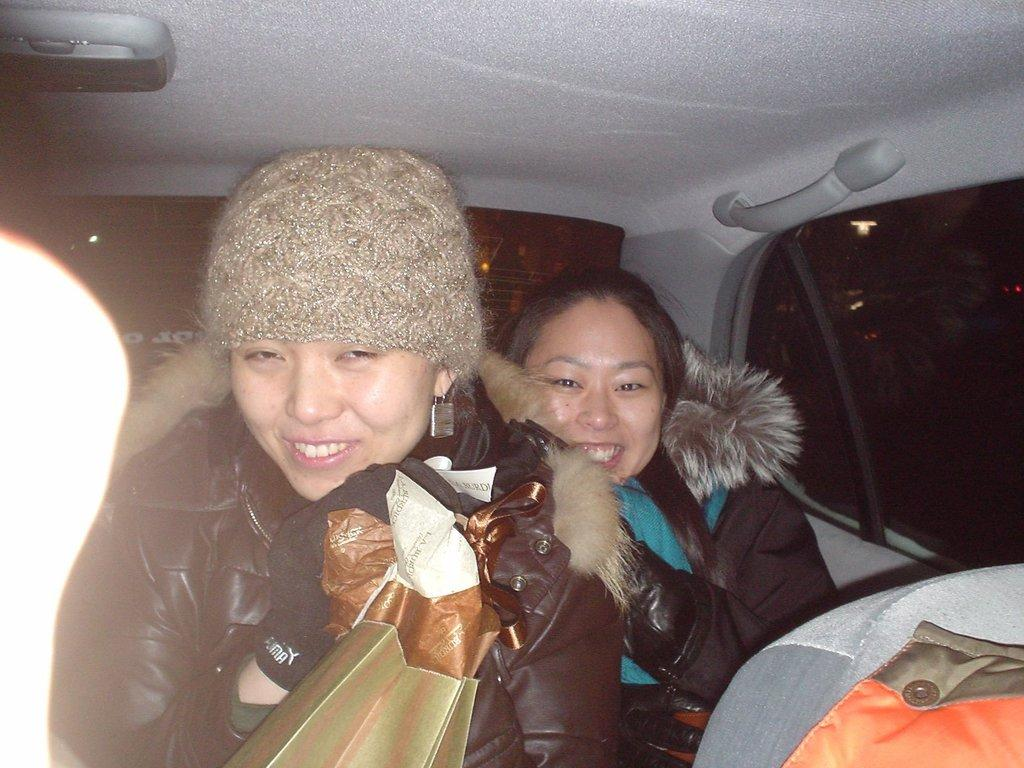How many people are in the image? There are two people in the image. What are the two people doing in the image? The two people are sitting in a car. What type of coal is being used to power the car in the image? There is no coal present in the image, and the car is not shown to be powered by coal. What effect does the coal have on the environment in the image? There is no coal or any indication of its environmental impact in the image. 